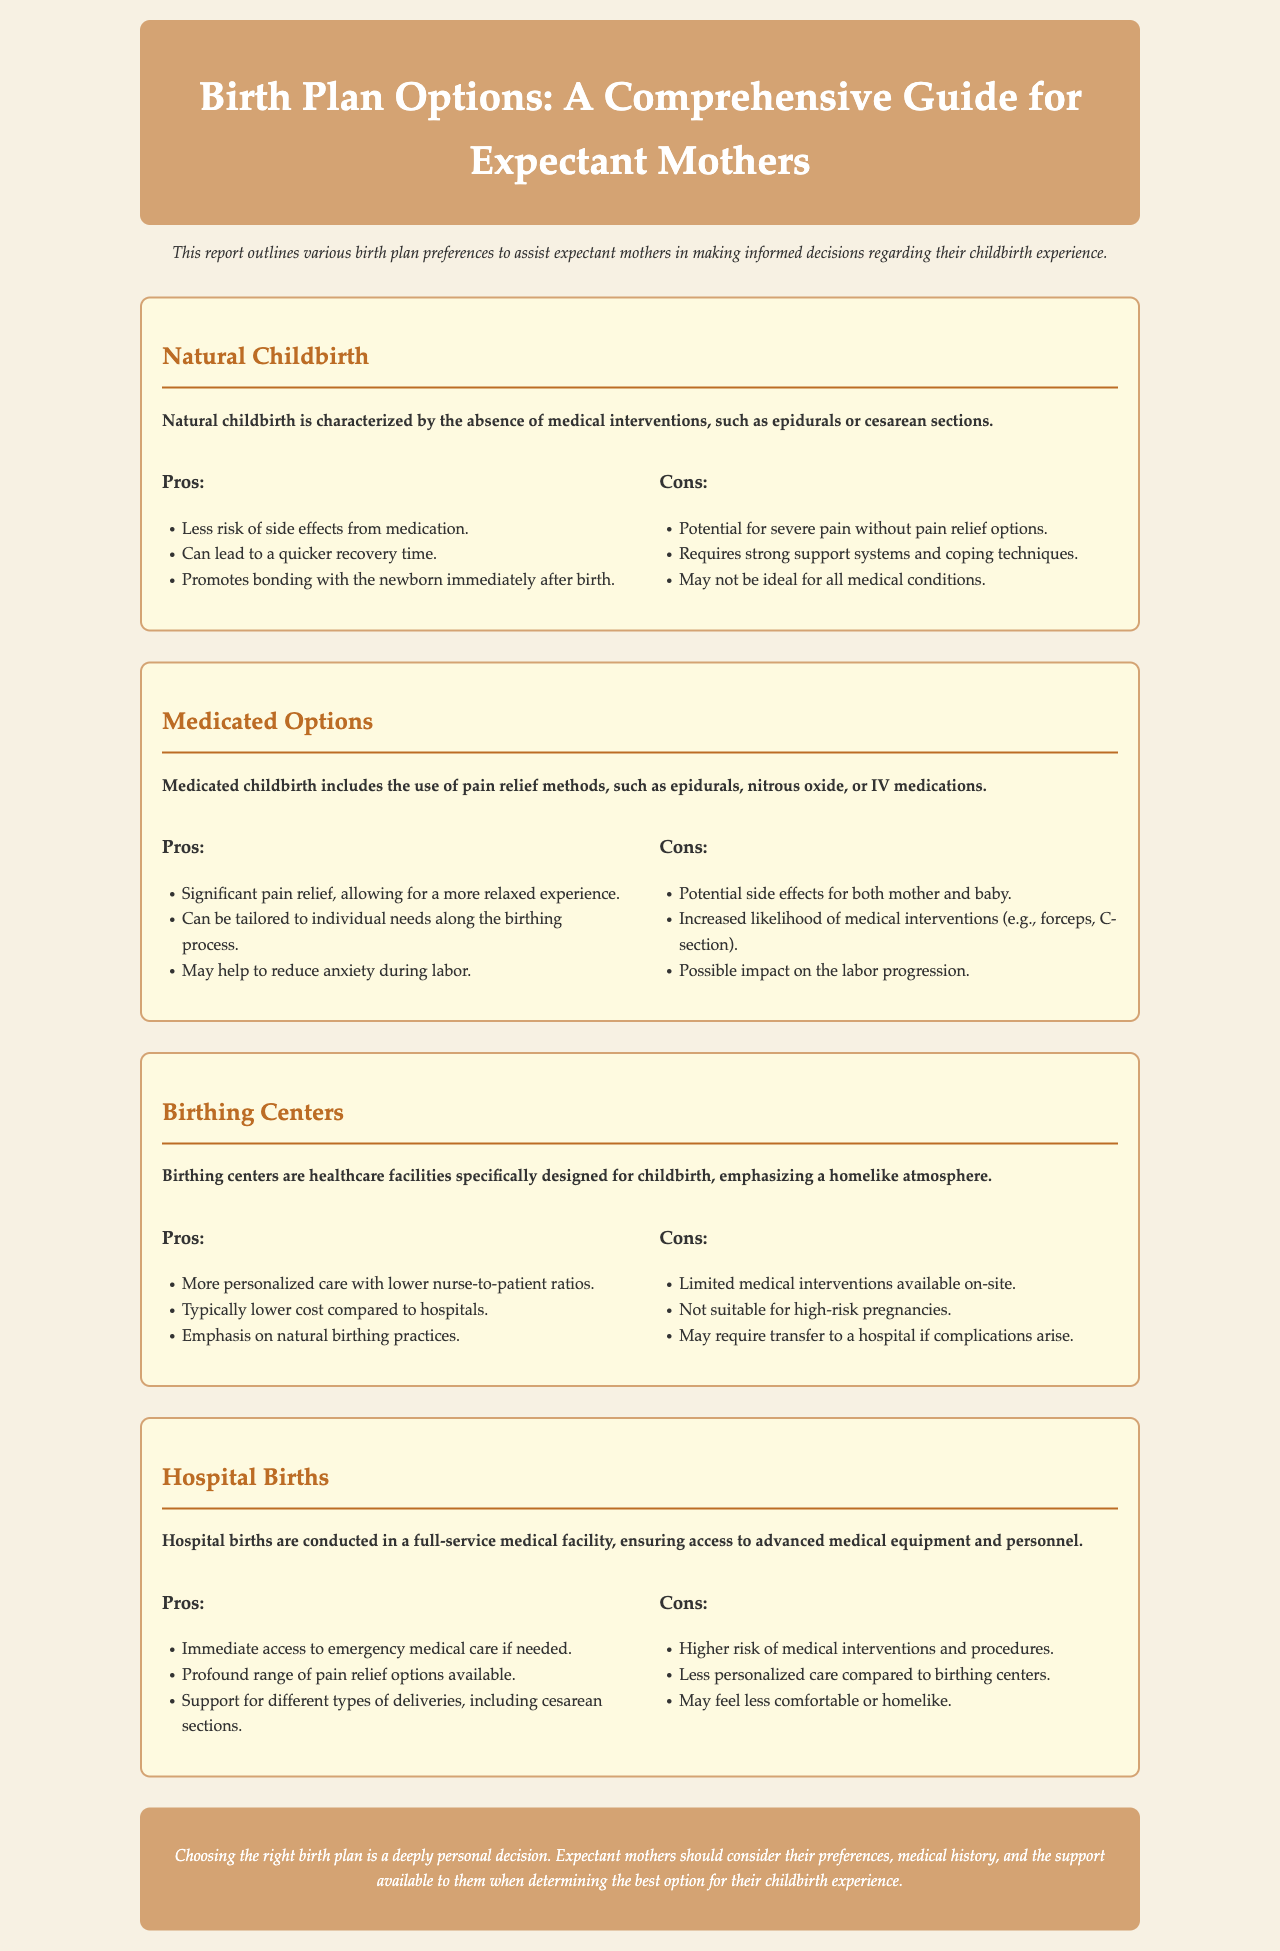What is natural childbirth characterized by? Natural childbirth is characterized by the absence of medical interventions, such as epidurals or cesarean sections.
Answer: Absence of medical interventions What is a key pro of medicated options? A significant pro of medicated options is significant pain relief, allowing for a more relaxed experience.
Answer: Significant pain relief What is one con of birthing centers? One significant con is that they have limited medical interventions available on-site.
Answer: Limited medical interventions What is the primary focus of hospital births? Hospital births ensure access to advanced medical equipment and personnel.
Answer: Advanced medical equipment and personnel What should expectant mothers consider when choosing a birth plan? Expectant mothers should consider their preferences, medical history, and the support available to them.
Answer: Preferences, medical history, support How many pros are listed for natural childbirth? There are three pros listed for natural childbirth.
Answer: Three pros What atmosphere do birthing centers emphasize? Birthing centers emphasize a homelike atmosphere.
Answer: Homelike atmosphere What type of delivery support is available in hospitals? Hospitals support different types of deliveries, including cesarean sections.
Answer: Cesarean sections What is the overall conclusion regarding choosing a birth plan? The conclusion emphasizes that choosing the right birth plan is a deeply personal decision.
Answer: Deeply personal decision 